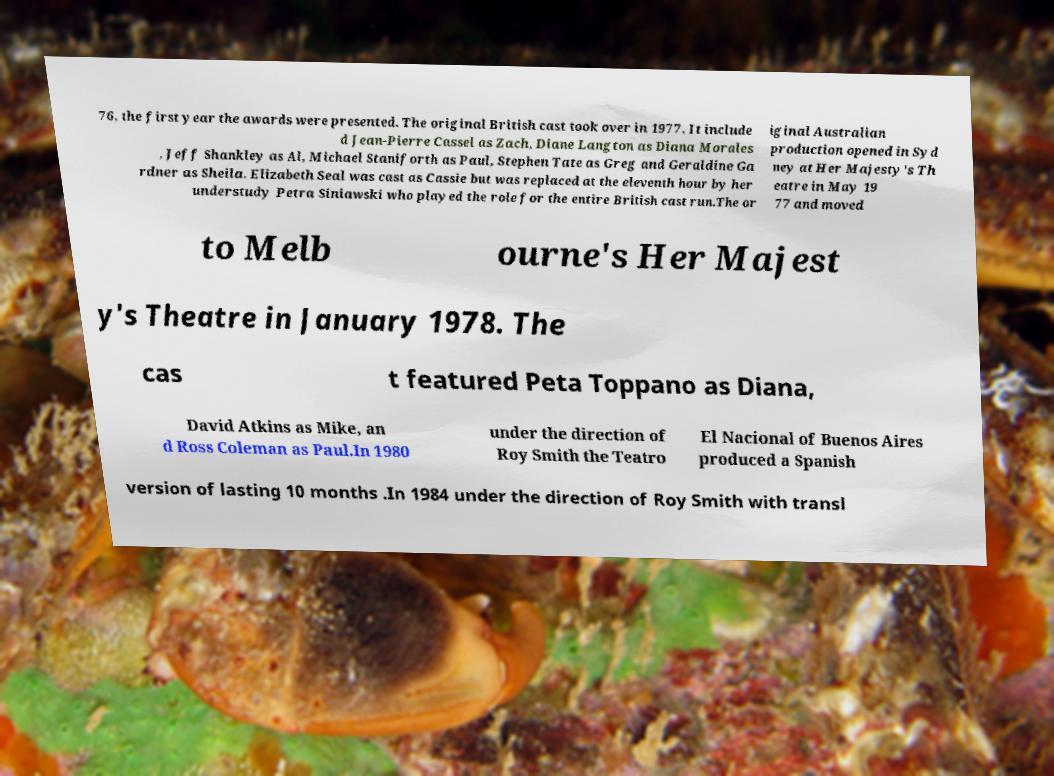For documentation purposes, I need the text within this image transcribed. Could you provide that? 76, the first year the awards were presented. The original British cast took over in 1977. It include d Jean-Pierre Cassel as Zach, Diane Langton as Diana Morales , Jeff Shankley as Al, Michael Staniforth as Paul, Stephen Tate as Greg and Geraldine Ga rdner as Sheila. Elizabeth Seal was cast as Cassie but was replaced at the eleventh hour by her understudy Petra Siniawski who played the role for the entire British cast run.The or iginal Australian production opened in Syd ney at Her Majesty's Th eatre in May 19 77 and moved to Melb ourne's Her Majest y's Theatre in January 1978. The cas t featured Peta Toppano as Diana, David Atkins as Mike, an d Ross Coleman as Paul.In 1980 under the direction of Roy Smith the Teatro El Nacional of Buenos Aires produced a Spanish version of lasting 10 months .In 1984 under the direction of Roy Smith with transl 